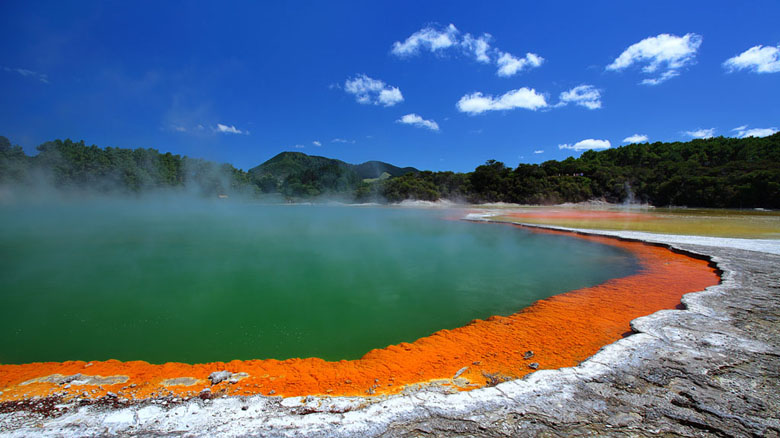What can you say about the different colors in the hot spring? The vivid colors of the hot spring are a result of various mineral deposits and microbial life thriving in the geothermal environment. The bright orange at the edges is primarily due to high concentrations of sulfur and iron oxide, which create a striking contrast against the green waters of the center, attributed to a type of algae that thrives in the hot, alkaline conditions. These colors serve as natural markers of the rich and diverse geochemical processes occurring beneath the Earth's surface. 